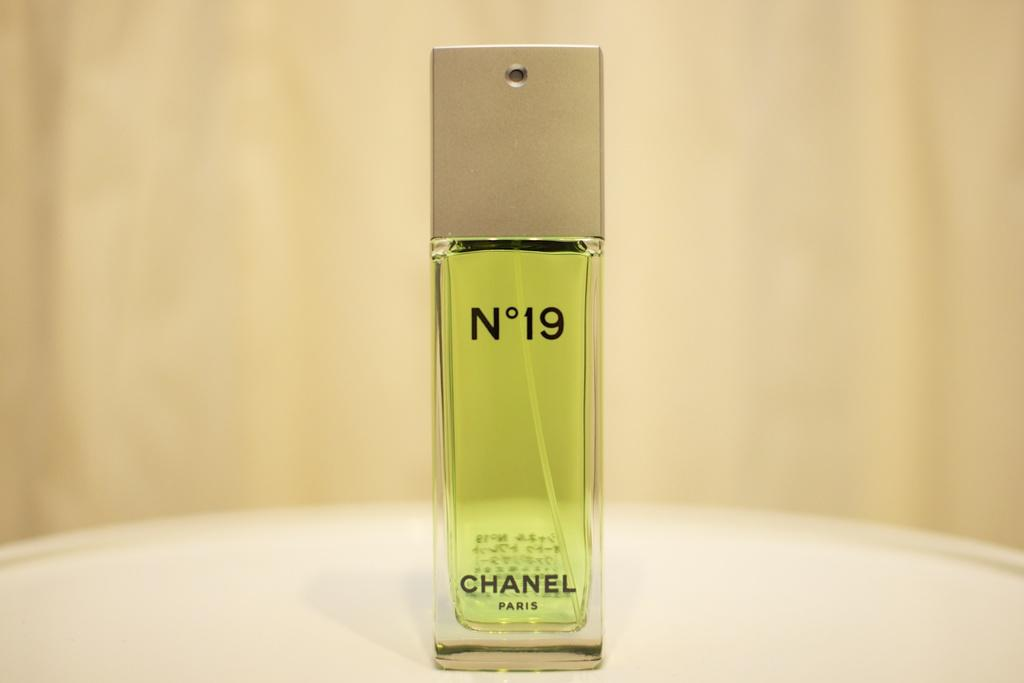<image>
Relay a brief, clear account of the picture shown. A perfume bottle of Chanel No 19 on a pedestal. 